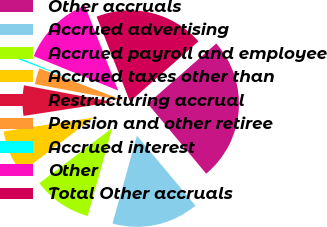Convert chart. <chart><loc_0><loc_0><loc_500><loc_500><pie_chart><fcel>Other accruals<fcel>Accrued advertising<fcel>Accrued payroll and employee<fcel>Accrued taxes other than<fcel>Restructuring accrual<fcel>Pension and other retiree<fcel>Accrued interest<fcel>Other<fcel>Total Other accruals<nl><fcel>25.4%<fcel>15.39%<fcel>10.38%<fcel>7.87%<fcel>5.37%<fcel>2.87%<fcel>0.36%<fcel>12.88%<fcel>19.48%<nl></chart> 